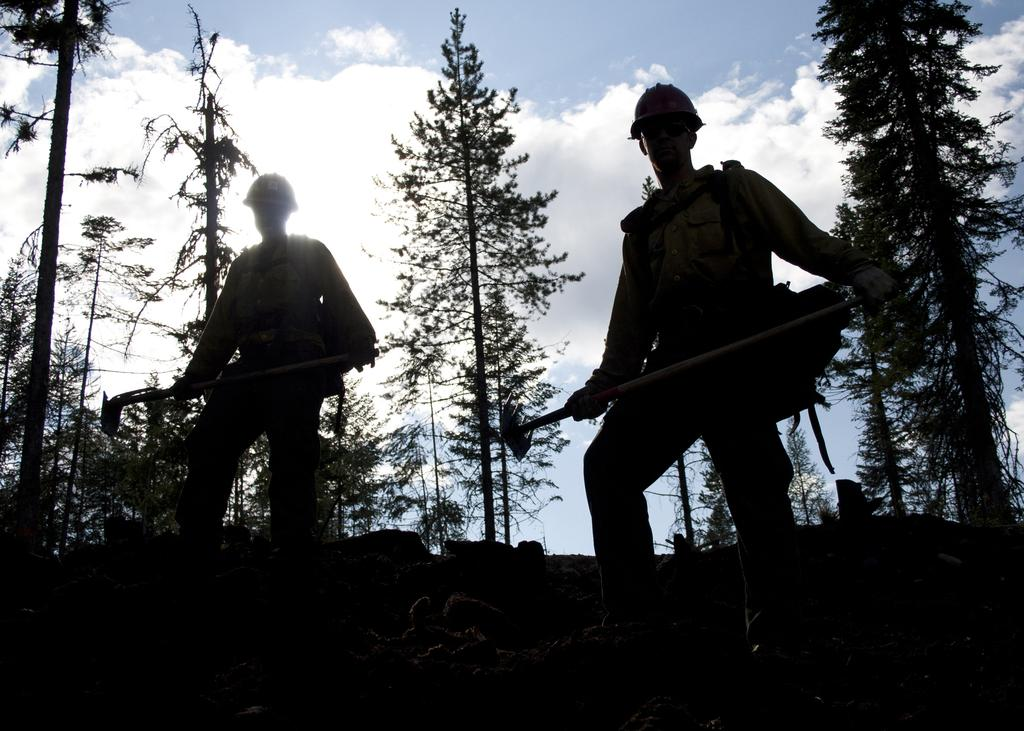How many people are in the image? There are two persons in the image. What are the persons doing in the image? The persons are standing and holding tools. What can be seen in the background of the image? There are trees and the sky visible in the background of the image. What type of wealth can be seen in the image? There is no indication of wealth in the image; it features two persons standing and holding tools. What type of net is being used by the persons in the image? There is no net present in the image; the persons are holding tools. 